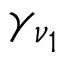Convert formula to latex. <formula><loc_0><loc_0><loc_500><loc_500>\gamma _ { \nu _ { 1 } }</formula> 